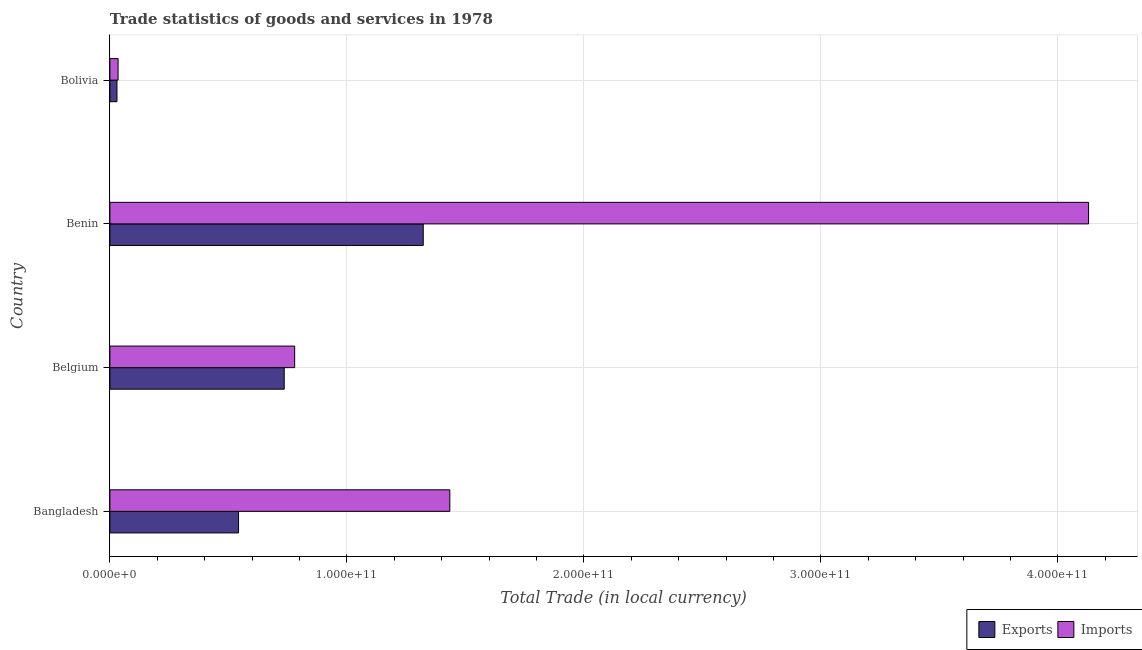How many bars are there on the 3rd tick from the top?
Offer a terse response. 2. What is the label of the 3rd group of bars from the top?
Your answer should be very brief. Belgium. What is the export of goods and services in Belgium?
Provide a short and direct response. 7.35e+1. Across all countries, what is the maximum export of goods and services?
Offer a very short reply. 1.32e+11. Across all countries, what is the minimum export of goods and services?
Provide a short and direct response. 2.99e+09. In which country was the export of goods and services maximum?
Make the answer very short. Benin. In which country was the imports of goods and services minimum?
Offer a terse response. Bolivia. What is the total export of goods and services in the graph?
Ensure brevity in your answer.  2.63e+11. What is the difference between the export of goods and services in Belgium and that in Benin?
Offer a very short reply. -5.87e+1. What is the difference between the export of goods and services in Benin and the imports of goods and services in Belgium?
Provide a short and direct response. 5.42e+1. What is the average imports of goods and services per country?
Your answer should be very brief. 1.59e+11. What is the difference between the export of goods and services and imports of goods and services in Bolivia?
Your answer should be compact. -4.70e+08. What is the ratio of the export of goods and services in Belgium to that in Benin?
Give a very brief answer. 0.56. Is the imports of goods and services in Belgium less than that in Bolivia?
Your answer should be very brief. No. Is the difference between the export of goods and services in Belgium and Bolivia greater than the difference between the imports of goods and services in Belgium and Bolivia?
Give a very brief answer. No. What is the difference between the highest and the second highest imports of goods and services?
Ensure brevity in your answer.  2.69e+11. What is the difference between the highest and the lowest export of goods and services?
Keep it short and to the point. 1.29e+11. Is the sum of the export of goods and services in Belgium and Bolivia greater than the maximum imports of goods and services across all countries?
Provide a succinct answer. No. What does the 1st bar from the top in Bangladesh represents?
Your answer should be compact. Imports. What does the 1st bar from the bottom in Benin represents?
Keep it short and to the point. Exports. What is the difference between two consecutive major ticks on the X-axis?
Your response must be concise. 1.00e+11. Does the graph contain any zero values?
Provide a succinct answer. No. Does the graph contain grids?
Keep it short and to the point. Yes. How are the legend labels stacked?
Provide a short and direct response. Horizontal. What is the title of the graph?
Ensure brevity in your answer.  Trade statistics of goods and services in 1978. What is the label or title of the X-axis?
Ensure brevity in your answer.  Total Trade (in local currency). What is the Total Trade (in local currency) in Exports in Bangladesh?
Offer a very short reply. 5.43e+1. What is the Total Trade (in local currency) in Imports in Bangladesh?
Offer a very short reply. 1.43e+11. What is the Total Trade (in local currency) in Exports in Belgium?
Keep it short and to the point. 7.35e+1. What is the Total Trade (in local currency) of Imports in Belgium?
Your answer should be compact. 7.80e+1. What is the Total Trade (in local currency) of Exports in Benin?
Provide a succinct answer. 1.32e+11. What is the Total Trade (in local currency) of Imports in Benin?
Give a very brief answer. 4.13e+11. What is the Total Trade (in local currency) in Exports in Bolivia?
Offer a terse response. 2.99e+09. What is the Total Trade (in local currency) of Imports in Bolivia?
Offer a very short reply. 3.46e+09. Across all countries, what is the maximum Total Trade (in local currency) of Exports?
Keep it short and to the point. 1.32e+11. Across all countries, what is the maximum Total Trade (in local currency) of Imports?
Your response must be concise. 4.13e+11. Across all countries, what is the minimum Total Trade (in local currency) of Exports?
Your answer should be very brief. 2.99e+09. Across all countries, what is the minimum Total Trade (in local currency) of Imports?
Make the answer very short. 3.46e+09. What is the total Total Trade (in local currency) of Exports in the graph?
Provide a short and direct response. 2.63e+11. What is the total Total Trade (in local currency) of Imports in the graph?
Make the answer very short. 6.38e+11. What is the difference between the Total Trade (in local currency) of Exports in Bangladesh and that in Belgium?
Make the answer very short. -1.93e+1. What is the difference between the Total Trade (in local currency) in Imports in Bangladesh and that in Belgium?
Ensure brevity in your answer.  6.55e+1. What is the difference between the Total Trade (in local currency) of Exports in Bangladesh and that in Benin?
Offer a very short reply. -7.79e+1. What is the difference between the Total Trade (in local currency) in Imports in Bangladesh and that in Benin?
Make the answer very short. -2.69e+11. What is the difference between the Total Trade (in local currency) in Exports in Bangladesh and that in Bolivia?
Give a very brief answer. 5.13e+1. What is the difference between the Total Trade (in local currency) of Imports in Bangladesh and that in Bolivia?
Provide a succinct answer. 1.40e+11. What is the difference between the Total Trade (in local currency) of Exports in Belgium and that in Benin?
Make the answer very short. -5.87e+1. What is the difference between the Total Trade (in local currency) in Imports in Belgium and that in Benin?
Ensure brevity in your answer.  -3.35e+11. What is the difference between the Total Trade (in local currency) in Exports in Belgium and that in Bolivia?
Give a very brief answer. 7.06e+1. What is the difference between the Total Trade (in local currency) of Imports in Belgium and that in Bolivia?
Ensure brevity in your answer.  7.45e+1. What is the difference between the Total Trade (in local currency) in Exports in Benin and that in Bolivia?
Offer a very short reply. 1.29e+11. What is the difference between the Total Trade (in local currency) of Imports in Benin and that in Bolivia?
Provide a short and direct response. 4.09e+11. What is the difference between the Total Trade (in local currency) of Exports in Bangladesh and the Total Trade (in local currency) of Imports in Belgium?
Offer a terse response. -2.37e+1. What is the difference between the Total Trade (in local currency) in Exports in Bangladesh and the Total Trade (in local currency) in Imports in Benin?
Offer a terse response. -3.59e+11. What is the difference between the Total Trade (in local currency) of Exports in Bangladesh and the Total Trade (in local currency) of Imports in Bolivia?
Your answer should be very brief. 5.08e+1. What is the difference between the Total Trade (in local currency) of Exports in Belgium and the Total Trade (in local currency) of Imports in Benin?
Give a very brief answer. -3.39e+11. What is the difference between the Total Trade (in local currency) in Exports in Belgium and the Total Trade (in local currency) in Imports in Bolivia?
Offer a very short reply. 7.01e+1. What is the difference between the Total Trade (in local currency) of Exports in Benin and the Total Trade (in local currency) of Imports in Bolivia?
Your response must be concise. 1.29e+11. What is the average Total Trade (in local currency) of Exports per country?
Offer a terse response. 6.58e+1. What is the average Total Trade (in local currency) in Imports per country?
Offer a terse response. 1.59e+11. What is the difference between the Total Trade (in local currency) of Exports and Total Trade (in local currency) of Imports in Bangladesh?
Provide a short and direct response. -8.91e+1. What is the difference between the Total Trade (in local currency) of Exports and Total Trade (in local currency) of Imports in Belgium?
Your answer should be very brief. -4.41e+09. What is the difference between the Total Trade (in local currency) of Exports and Total Trade (in local currency) of Imports in Benin?
Your answer should be compact. -2.81e+11. What is the difference between the Total Trade (in local currency) in Exports and Total Trade (in local currency) in Imports in Bolivia?
Offer a terse response. -4.70e+08. What is the ratio of the Total Trade (in local currency) of Exports in Bangladesh to that in Belgium?
Provide a short and direct response. 0.74. What is the ratio of the Total Trade (in local currency) of Imports in Bangladesh to that in Belgium?
Your answer should be compact. 1.84. What is the ratio of the Total Trade (in local currency) of Exports in Bangladesh to that in Benin?
Make the answer very short. 0.41. What is the ratio of the Total Trade (in local currency) in Imports in Bangladesh to that in Benin?
Offer a terse response. 0.35. What is the ratio of the Total Trade (in local currency) in Exports in Bangladesh to that in Bolivia?
Your answer should be very brief. 18.17. What is the ratio of the Total Trade (in local currency) in Imports in Bangladesh to that in Bolivia?
Ensure brevity in your answer.  41.48. What is the ratio of the Total Trade (in local currency) in Exports in Belgium to that in Benin?
Make the answer very short. 0.56. What is the ratio of the Total Trade (in local currency) in Imports in Belgium to that in Benin?
Provide a succinct answer. 0.19. What is the ratio of the Total Trade (in local currency) of Exports in Belgium to that in Bolivia?
Your answer should be compact. 24.62. What is the ratio of the Total Trade (in local currency) of Imports in Belgium to that in Bolivia?
Offer a very short reply. 22.55. What is the ratio of the Total Trade (in local currency) in Exports in Benin to that in Bolivia?
Your response must be concise. 44.25. What is the ratio of the Total Trade (in local currency) of Imports in Benin to that in Bolivia?
Offer a very short reply. 119.42. What is the difference between the highest and the second highest Total Trade (in local currency) of Exports?
Provide a succinct answer. 5.87e+1. What is the difference between the highest and the second highest Total Trade (in local currency) in Imports?
Your answer should be very brief. 2.69e+11. What is the difference between the highest and the lowest Total Trade (in local currency) in Exports?
Provide a short and direct response. 1.29e+11. What is the difference between the highest and the lowest Total Trade (in local currency) of Imports?
Provide a succinct answer. 4.09e+11. 